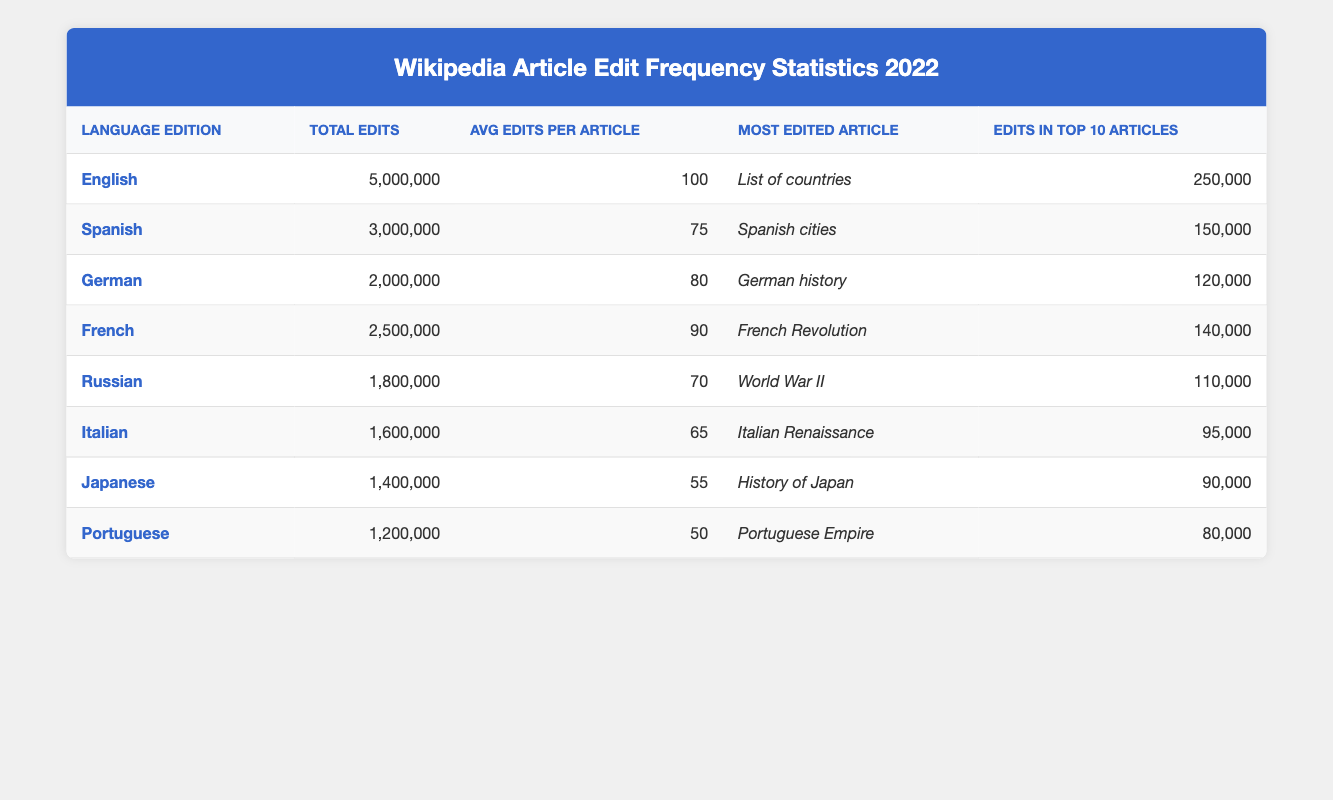What is the most edited article in the English language edition? The table indicates that the most edited article in the English language edition is "List of countries."
Answer: List of countries Which language edition had the highest total number of edits? By comparing the total edits column, the English language edition has the highest total with 5,000,000 edits.
Answer: English What is the average number of edits per article for the Spanish language edition? The table shows that the average edits per article for the Spanish language edition is 75.
Answer: 75 Is it true that the French language edition had more total edits than the German language edition? The total edits for the French language edition is 2,500,000, while for the German edition it is 2,000,000. This confirms that the French edition had more total edits.
Answer: Yes What is the combined total of edits from the German and Italian language editions? The total edits for the German edition is 2,000,000 and for the Italian edition is 1,600,000. Adding these gives 2,000,000 + 1,600,000 = 3,600,000.
Answer: 3,600,000 Which language edition had the lowest average edits per article? Looking at the average edits per article, Portuguese has the lowest value of 50 which is less than all other language editions.
Answer: Portuguese How many edits were made in the top 10 articles for the Japanese language edition? The table specifies that the edits in the top 10 articles for the Japanese edition amount to 90,000.
Answer: 90,000 How does the average edits per article for the Russian language edition compare to the Spanish language edition? The average for the Russian edition is 70 while the Spanish edition is 75, meaning the Russian edition has fewer average edits per article.
Answer: Russian has fewer What is the difference in total edits between the French and Spanish language editions? Total edits are 2,500,000 for French and 3,000,000 for Spanish. The difference is 3,000,000 - 2,500,000 = 500,000 edits.
Answer: 500,000 